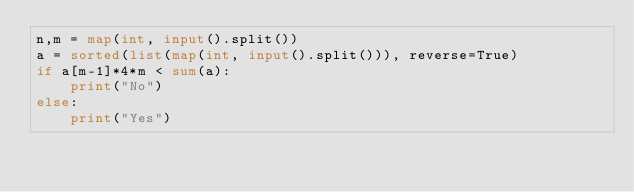<code> <loc_0><loc_0><loc_500><loc_500><_Python_>n,m = map(int, input().split())
a = sorted(list(map(int, input().split())), reverse=True)
if a[m-1]*4*m < sum(a):
    print("No")
else:
    print("Yes")</code> 